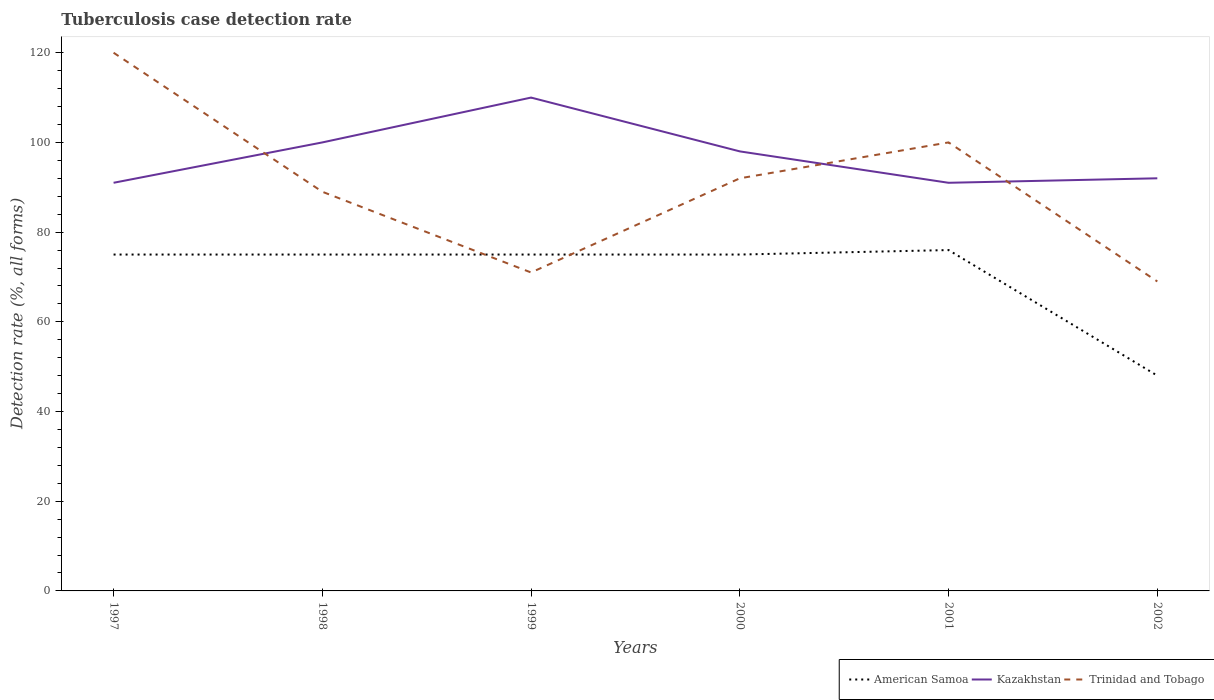Is the number of lines equal to the number of legend labels?
Offer a terse response. Yes. Across all years, what is the maximum tuberculosis case detection rate in in Kazakhstan?
Give a very brief answer. 91. In which year was the tuberculosis case detection rate in in American Samoa maximum?
Provide a short and direct response. 2002. What is the total tuberculosis case detection rate in in Trinidad and Tobago in the graph?
Your answer should be very brief. 31. What is the difference between the highest and the second highest tuberculosis case detection rate in in American Samoa?
Keep it short and to the point. 28. What is the difference between two consecutive major ticks on the Y-axis?
Provide a short and direct response. 20. Does the graph contain any zero values?
Ensure brevity in your answer.  No. Does the graph contain grids?
Your response must be concise. No. Where does the legend appear in the graph?
Your answer should be very brief. Bottom right. How many legend labels are there?
Make the answer very short. 3. How are the legend labels stacked?
Provide a short and direct response. Horizontal. What is the title of the graph?
Provide a short and direct response. Tuberculosis case detection rate. What is the label or title of the X-axis?
Provide a short and direct response. Years. What is the label or title of the Y-axis?
Provide a short and direct response. Detection rate (%, all forms). What is the Detection rate (%, all forms) in American Samoa in 1997?
Your response must be concise. 75. What is the Detection rate (%, all forms) in Kazakhstan in 1997?
Offer a terse response. 91. What is the Detection rate (%, all forms) of Trinidad and Tobago in 1997?
Provide a short and direct response. 120. What is the Detection rate (%, all forms) of Trinidad and Tobago in 1998?
Offer a very short reply. 89. What is the Detection rate (%, all forms) in American Samoa in 1999?
Your answer should be very brief. 75. What is the Detection rate (%, all forms) in Kazakhstan in 1999?
Provide a short and direct response. 110. What is the Detection rate (%, all forms) in Trinidad and Tobago in 2000?
Give a very brief answer. 92. What is the Detection rate (%, all forms) of Kazakhstan in 2001?
Your answer should be very brief. 91. What is the Detection rate (%, all forms) in Trinidad and Tobago in 2001?
Your answer should be compact. 100. What is the Detection rate (%, all forms) of American Samoa in 2002?
Your response must be concise. 48. What is the Detection rate (%, all forms) of Kazakhstan in 2002?
Your answer should be compact. 92. What is the Detection rate (%, all forms) of Trinidad and Tobago in 2002?
Offer a very short reply. 69. Across all years, what is the maximum Detection rate (%, all forms) of American Samoa?
Offer a very short reply. 76. Across all years, what is the maximum Detection rate (%, all forms) of Kazakhstan?
Provide a succinct answer. 110. Across all years, what is the maximum Detection rate (%, all forms) in Trinidad and Tobago?
Ensure brevity in your answer.  120. Across all years, what is the minimum Detection rate (%, all forms) in American Samoa?
Keep it short and to the point. 48. Across all years, what is the minimum Detection rate (%, all forms) of Kazakhstan?
Your answer should be very brief. 91. What is the total Detection rate (%, all forms) in American Samoa in the graph?
Offer a very short reply. 424. What is the total Detection rate (%, all forms) of Kazakhstan in the graph?
Your response must be concise. 582. What is the total Detection rate (%, all forms) in Trinidad and Tobago in the graph?
Make the answer very short. 541. What is the difference between the Detection rate (%, all forms) in American Samoa in 1997 and that in 1998?
Make the answer very short. 0. What is the difference between the Detection rate (%, all forms) of Trinidad and Tobago in 1997 and that in 1999?
Your answer should be compact. 49. What is the difference between the Detection rate (%, all forms) in Kazakhstan in 1997 and that in 2000?
Provide a succinct answer. -7. What is the difference between the Detection rate (%, all forms) of Kazakhstan in 1997 and that in 2001?
Provide a succinct answer. 0. What is the difference between the Detection rate (%, all forms) in Trinidad and Tobago in 1997 and that in 2001?
Offer a very short reply. 20. What is the difference between the Detection rate (%, all forms) in American Samoa in 1997 and that in 2002?
Give a very brief answer. 27. What is the difference between the Detection rate (%, all forms) of Kazakhstan in 1997 and that in 2002?
Ensure brevity in your answer.  -1. What is the difference between the Detection rate (%, all forms) in Trinidad and Tobago in 1997 and that in 2002?
Ensure brevity in your answer.  51. What is the difference between the Detection rate (%, all forms) in Kazakhstan in 1998 and that in 1999?
Provide a succinct answer. -10. What is the difference between the Detection rate (%, all forms) of Kazakhstan in 1998 and that in 2002?
Your answer should be very brief. 8. What is the difference between the Detection rate (%, all forms) in Trinidad and Tobago in 1998 and that in 2002?
Offer a terse response. 20. What is the difference between the Detection rate (%, all forms) of American Samoa in 1999 and that in 2001?
Ensure brevity in your answer.  -1. What is the difference between the Detection rate (%, all forms) of Kazakhstan in 1999 and that in 2002?
Your response must be concise. 18. What is the difference between the Detection rate (%, all forms) of Trinidad and Tobago in 2000 and that in 2001?
Make the answer very short. -8. What is the difference between the Detection rate (%, all forms) of Trinidad and Tobago in 2000 and that in 2002?
Offer a terse response. 23. What is the difference between the Detection rate (%, all forms) in American Samoa in 2001 and that in 2002?
Your answer should be very brief. 28. What is the difference between the Detection rate (%, all forms) of Trinidad and Tobago in 2001 and that in 2002?
Your response must be concise. 31. What is the difference between the Detection rate (%, all forms) of American Samoa in 1997 and the Detection rate (%, all forms) of Kazakhstan in 1998?
Keep it short and to the point. -25. What is the difference between the Detection rate (%, all forms) in American Samoa in 1997 and the Detection rate (%, all forms) in Trinidad and Tobago in 1998?
Provide a succinct answer. -14. What is the difference between the Detection rate (%, all forms) in Kazakhstan in 1997 and the Detection rate (%, all forms) in Trinidad and Tobago in 1998?
Offer a very short reply. 2. What is the difference between the Detection rate (%, all forms) in American Samoa in 1997 and the Detection rate (%, all forms) in Kazakhstan in 1999?
Your answer should be very brief. -35. What is the difference between the Detection rate (%, all forms) of American Samoa in 1997 and the Detection rate (%, all forms) of Trinidad and Tobago in 1999?
Your response must be concise. 4. What is the difference between the Detection rate (%, all forms) of American Samoa in 1997 and the Detection rate (%, all forms) of Trinidad and Tobago in 2000?
Give a very brief answer. -17. What is the difference between the Detection rate (%, all forms) of Kazakhstan in 1997 and the Detection rate (%, all forms) of Trinidad and Tobago in 2000?
Provide a succinct answer. -1. What is the difference between the Detection rate (%, all forms) of American Samoa in 1997 and the Detection rate (%, all forms) of Kazakhstan in 2001?
Your answer should be very brief. -16. What is the difference between the Detection rate (%, all forms) in Kazakhstan in 1997 and the Detection rate (%, all forms) in Trinidad and Tobago in 2001?
Ensure brevity in your answer.  -9. What is the difference between the Detection rate (%, all forms) of American Samoa in 1997 and the Detection rate (%, all forms) of Kazakhstan in 2002?
Give a very brief answer. -17. What is the difference between the Detection rate (%, all forms) of American Samoa in 1997 and the Detection rate (%, all forms) of Trinidad and Tobago in 2002?
Provide a short and direct response. 6. What is the difference between the Detection rate (%, all forms) of American Samoa in 1998 and the Detection rate (%, all forms) of Kazakhstan in 1999?
Provide a short and direct response. -35. What is the difference between the Detection rate (%, all forms) in Kazakhstan in 1998 and the Detection rate (%, all forms) in Trinidad and Tobago in 1999?
Make the answer very short. 29. What is the difference between the Detection rate (%, all forms) in American Samoa in 1998 and the Detection rate (%, all forms) in Kazakhstan in 2000?
Offer a terse response. -23. What is the difference between the Detection rate (%, all forms) in American Samoa in 1998 and the Detection rate (%, all forms) in Kazakhstan in 2001?
Ensure brevity in your answer.  -16. What is the difference between the Detection rate (%, all forms) of American Samoa in 1998 and the Detection rate (%, all forms) of Trinidad and Tobago in 2002?
Your answer should be compact. 6. What is the difference between the Detection rate (%, all forms) in American Samoa in 1999 and the Detection rate (%, all forms) in Trinidad and Tobago in 2000?
Your response must be concise. -17. What is the difference between the Detection rate (%, all forms) of Kazakhstan in 1999 and the Detection rate (%, all forms) of Trinidad and Tobago in 2000?
Ensure brevity in your answer.  18. What is the difference between the Detection rate (%, all forms) in American Samoa in 1999 and the Detection rate (%, all forms) in Kazakhstan in 2001?
Your answer should be compact. -16. What is the difference between the Detection rate (%, all forms) in Kazakhstan in 1999 and the Detection rate (%, all forms) in Trinidad and Tobago in 2001?
Your answer should be very brief. 10. What is the difference between the Detection rate (%, all forms) in American Samoa in 1999 and the Detection rate (%, all forms) in Kazakhstan in 2002?
Your answer should be compact. -17. What is the difference between the Detection rate (%, all forms) of Kazakhstan in 2000 and the Detection rate (%, all forms) of Trinidad and Tobago in 2002?
Keep it short and to the point. 29. What is the average Detection rate (%, all forms) in American Samoa per year?
Provide a succinct answer. 70.67. What is the average Detection rate (%, all forms) of Kazakhstan per year?
Ensure brevity in your answer.  97. What is the average Detection rate (%, all forms) of Trinidad and Tobago per year?
Ensure brevity in your answer.  90.17. In the year 1997, what is the difference between the Detection rate (%, all forms) in American Samoa and Detection rate (%, all forms) in Kazakhstan?
Make the answer very short. -16. In the year 1997, what is the difference between the Detection rate (%, all forms) in American Samoa and Detection rate (%, all forms) in Trinidad and Tobago?
Your answer should be very brief. -45. In the year 1997, what is the difference between the Detection rate (%, all forms) of Kazakhstan and Detection rate (%, all forms) of Trinidad and Tobago?
Provide a short and direct response. -29. In the year 1998, what is the difference between the Detection rate (%, all forms) in American Samoa and Detection rate (%, all forms) in Trinidad and Tobago?
Give a very brief answer. -14. In the year 1998, what is the difference between the Detection rate (%, all forms) of Kazakhstan and Detection rate (%, all forms) of Trinidad and Tobago?
Your answer should be very brief. 11. In the year 1999, what is the difference between the Detection rate (%, all forms) of American Samoa and Detection rate (%, all forms) of Kazakhstan?
Make the answer very short. -35. In the year 1999, what is the difference between the Detection rate (%, all forms) of Kazakhstan and Detection rate (%, all forms) of Trinidad and Tobago?
Your answer should be compact. 39. In the year 2001, what is the difference between the Detection rate (%, all forms) of Kazakhstan and Detection rate (%, all forms) of Trinidad and Tobago?
Provide a short and direct response. -9. In the year 2002, what is the difference between the Detection rate (%, all forms) in American Samoa and Detection rate (%, all forms) in Kazakhstan?
Offer a terse response. -44. In the year 2002, what is the difference between the Detection rate (%, all forms) in American Samoa and Detection rate (%, all forms) in Trinidad and Tobago?
Provide a short and direct response. -21. What is the ratio of the Detection rate (%, all forms) in American Samoa in 1997 to that in 1998?
Make the answer very short. 1. What is the ratio of the Detection rate (%, all forms) of Kazakhstan in 1997 to that in 1998?
Ensure brevity in your answer.  0.91. What is the ratio of the Detection rate (%, all forms) of Trinidad and Tobago in 1997 to that in 1998?
Your answer should be very brief. 1.35. What is the ratio of the Detection rate (%, all forms) in American Samoa in 1997 to that in 1999?
Make the answer very short. 1. What is the ratio of the Detection rate (%, all forms) of Kazakhstan in 1997 to that in 1999?
Give a very brief answer. 0.83. What is the ratio of the Detection rate (%, all forms) in Trinidad and Tobago in 1997 to that in 1999?
Ensure brevity in your answer.  1.69. What is the ratio of the Detection rate (%, all forms) of American Samoa in 1997 to that in 2000?
Ensure brevity in your answer.  1. What is the ratio of the Detection rate (%, all forms) in Kazakhstan in 1997 to that in 2000?
Give a very brief answer. 0.93. What is the ratio of the Detection rate (%, all forms) of Trinidad and Tobago in 1997 to that in 2000?
Make the answer very short. 1.3. What is the ratio of the Detection rate (%, all forms) in Kazakhstan in 1997 to that in 2001?
Offer a terse response. 1. What is the ratio of the Detection rate (%, all forms) of American Samoa in 1997 to that in 2002?
Offer a very short reply. 1.56. What is the ratio of the Detection rate (%, all forms) of Kazakhstan in 1997 to that in 2002?
Your answer should be very brief. 0.99. What is the ratio of the Detection rate (%, all forms) in Trinidad and Tobago in 1997 to that in 2002?
Your answer should be very brief. 1.74. What is the ratio of the Detection rate (%, all forms) of Kazakhstan in 1998 to that in 1999?
Keep it short and to the point. 0.91. What is the ratio of the Detection rate (%, all forms) in Trinidad and Tobago in 1998 to that in 1999?
Your answer should be compact. 1.25. What is the ratio of the Detection rate (%, all forms) of Kazakhstan in 1998 to that in 2000?
Make the answer very short. 1.02. What is the ratio of the Detection rate (%, all forms) of Trinidad and Tobago in 1998 to that in 2000?
Your answer should be compact. 0.97. What is the ratio of the Detection rate (%, all forms) of Kazakhstan in 1998 to that in 2001?
Provide a succinct answer. 1.1. What is the ratio of the Detection rate (%, all forms) of Trinidad and Tobago in 1998 to that in 2001?
Your response must be concise. 0.89. What is the ratio of the Detection rate (%, all forms) of American Samoa in 1998 to that in 2002?
Offer a very short reply. 1.56. What is the ratio of the Detection rate (%, all forms) in Kazakhstan in 1998 to that in 2002?
Offer a terse response. 1.09. What is the ratio of the Detection rate (%, all forms) of Trinidad and Tobago in 1998 to that in 2002?
Offer a terse response. 1.29. What is the ratio of the Detection rate (%, all forms) in American Samoa in 1999 to that in 2000?
Keep it short and to the point. 1. What is the ratio of the Detection rate (%, all forms) in Kazakhstan in 1999 to that in 2000?
Offer a terse response. 1.12. What is the ratio of the Detection rate (%, all forms) of Trinidad and Tobago in 1999 to that in 2000?
Keep it short and to the point. 0.77. What is the ratio of the Detection rate (%, all forms) in Kazakhstan in 1999 to that in 2001?
Your answer should be compact. 1.21. What is the ratio of the Detection rate (%, all forms) in Trinidad and Tobago in 1999 to that in 2001?
Provide a succinct answer. 0.71. What is the ratio of the Detection rate (%, all forms) of American Samoa in 1999 to that in 2002?
Provide a succinct answer. 1.56. What is the ratio of the Detection rate (%, all forms) in Kazakhstan in 1999 to that in 2002?
Your response must be concise. 1.2. What is the ratio of the Detection rate (%, all forms) of Trinidad and Tobago in 1999 to that in 2002?
Keep it short and to the point. 1.03. What is the ratio of the Detection rate (%, all forms) of American Samoa in 2000 to that in 2001?
Keep it short and to the point. 0.99. What is the ratio of the Detection rate (%, all forms) of Kazakhstan in 2000 to that in 2001?
Ensure brevity in your answer.  1.08. What is the ratio of the Detection rate (%, all forms) of Trinidad and Tobago in 2000 to that in 2001?
Give a very brief answer. 0.92. What is the ratio of the Detection rate (%, all forms) in American Samoa in 2000 to that in 2002?
Give a very brief answer. 1.56. What is the ratio of the Detection rate (%, all forms) of Kazakhstan in 2000 to that in 2002?
Your answer should be compact. 1.07. What is the ratio of the Detection rate (%, all forms) in American Samoa in 2001 to that in 2002?
Your answer should be compact. 1.58. What is the ratio of the Detection rate (%, all forms) in Trinidad and Tobago in 2001 to that in 2002?
Your response must be concise. 1.45. What is the difference between the highest and the lowest Detection rate (%, all forms) in Kazakhstan?
Make the answer very short. 19. What is the difference between the highest and the lowest Detection rate (%, all forms) of Trinidad and Tobago?
Ensure brevity in your answer.  51. 